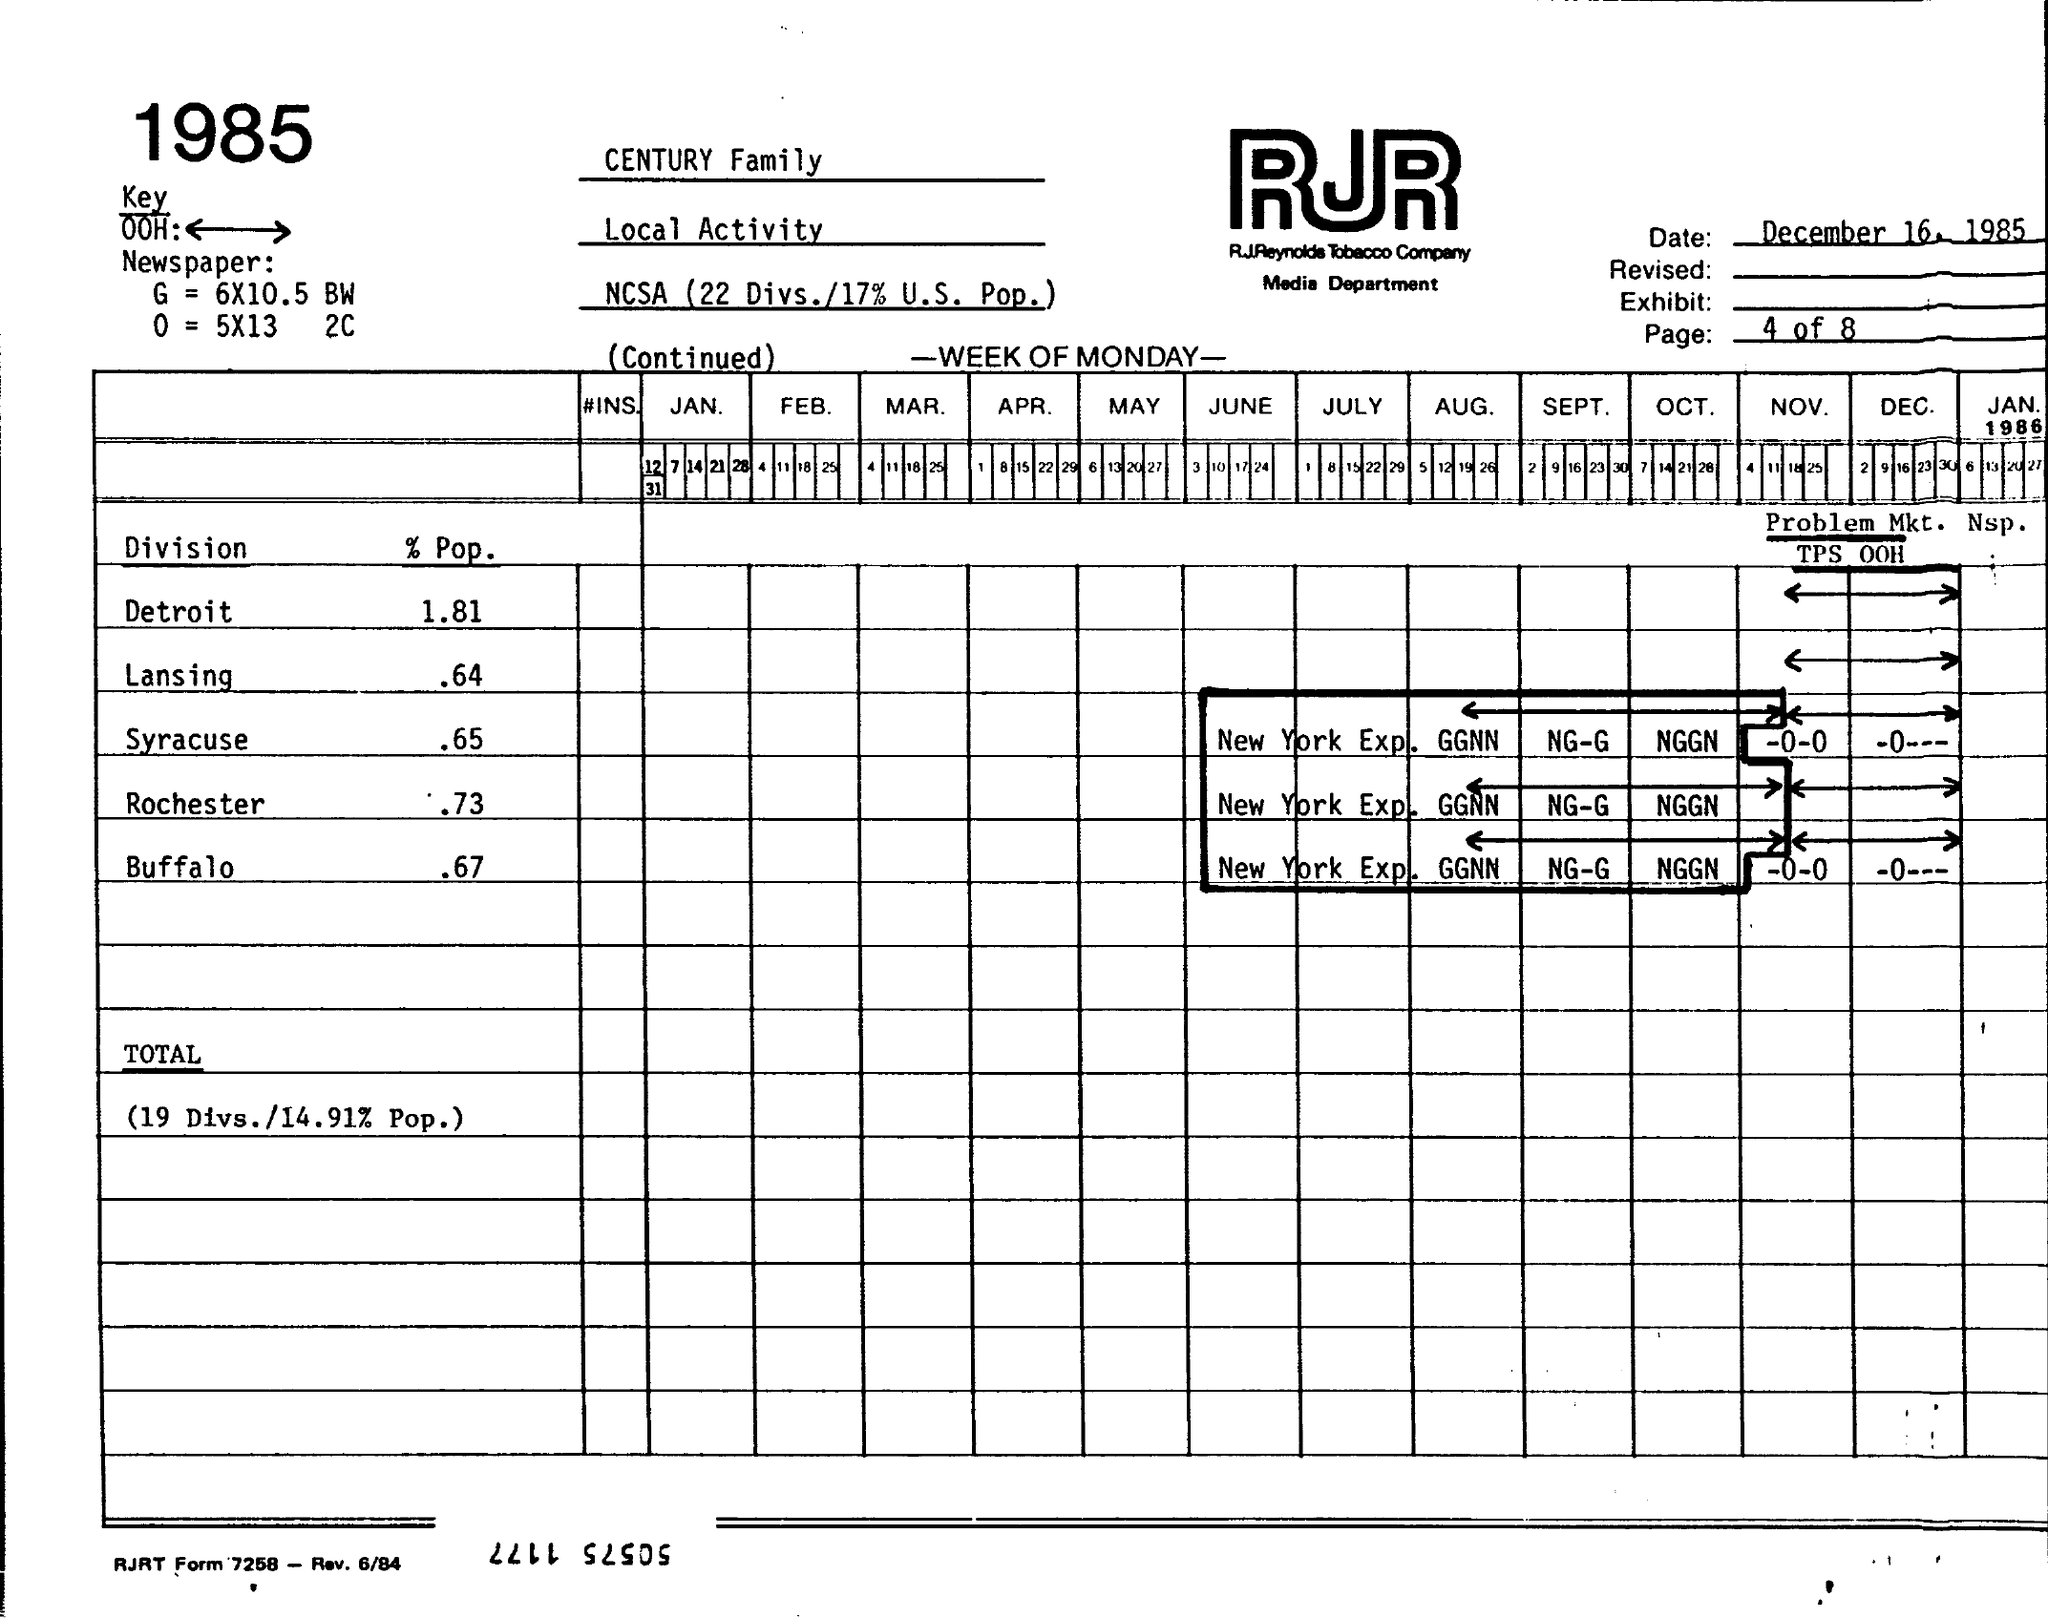Explain the codes, like 'NG-G' and 'NGGN', noted in the rightmost columns. The codes 'NG-G' and 'NGGN' in the document might be internal shorthand or classification used by the RJR Reynolds Tobacco Company for tracking different marketing or sales activities. They could represent campaign status, market types, or other operational details specific to the company. 